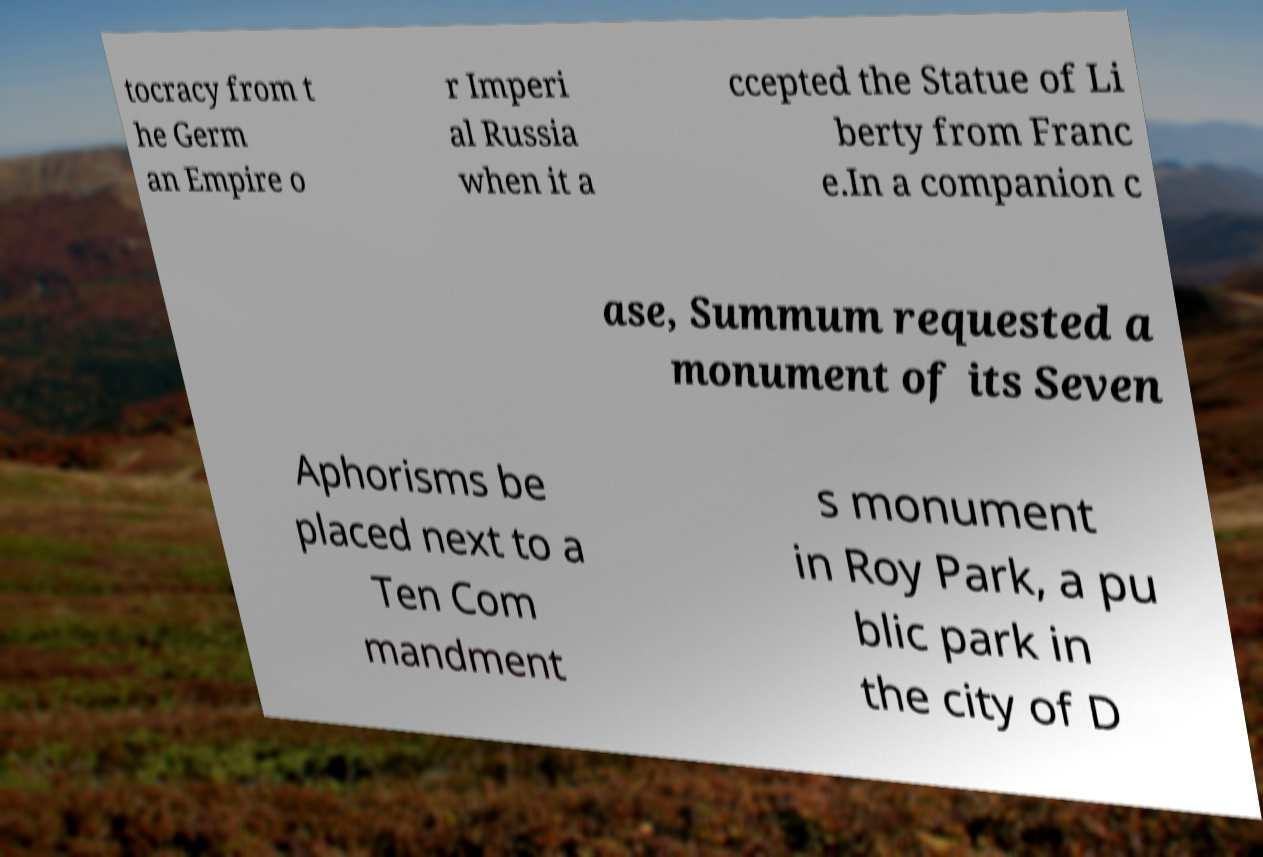Can you read and provide the text displayed in the image?This photo seems to have some interesting text. Can you extract and type it out for me? tocracy from t he Germ an Empire o r Imperi al Russia when it a ccepted the Statue of Li berty from Franc e.In a companion c ase, Summum requested a monument of its Seven Aphorisms be placed next to a Ten Com mandment s monument in Roy Park, a pu blic park in the city of D 